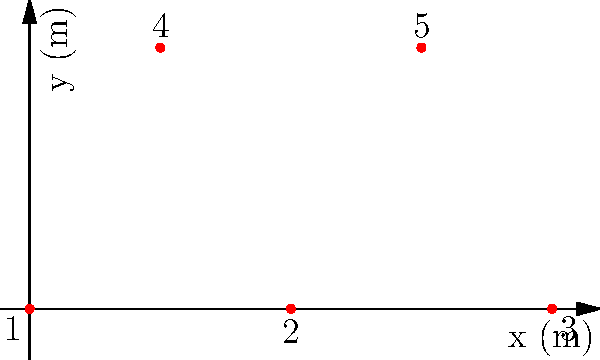In a traditional Nepalese dance formation, five dancers are positioned as shown in the diagram. Each dancer has a mass of 60 kg. Calculate the x-coordinate of the center of mass for this group of dancers. To find the x-coordinate of the center of mass, we'll follow these steps:

1) The formula for the x-coordinate of the center of mass is:

   $$x_{CM} = \frac{\sum_{i=1}^n m_i x_i}{\sum_{i=1}^n m_i}$$

   Where $m_i$ is the mass of each dancer and $x_i$ is their x-coordinate.

2) All dancers have the same mass (60 kg), so we can simplify:

   $$x_{CM} = \frac{60(x_1 + x_2 + x_3 + x_4 + x_5)}{60 \cdot 5} = \frac{x_1 + x_2 + x_3 + x_4 + x_5}{5}$$

3) From the diagram, we can see the x-coordinates:
   Dancer 1: 0 m
   Dancer 2: 2 m
   Dancer 3: 4 m
   Dancer 4: 1 m
   Dancer 5: 3 m

4) Substituting these values:

   $$x_{CM} = \frac{0 + 2 + 4 + 1 + 3}{5} = \frac{10}{5} = 2$$

Therefore, the x-coordinate of the center of mass is 2 meters.
Answer: 2 m 